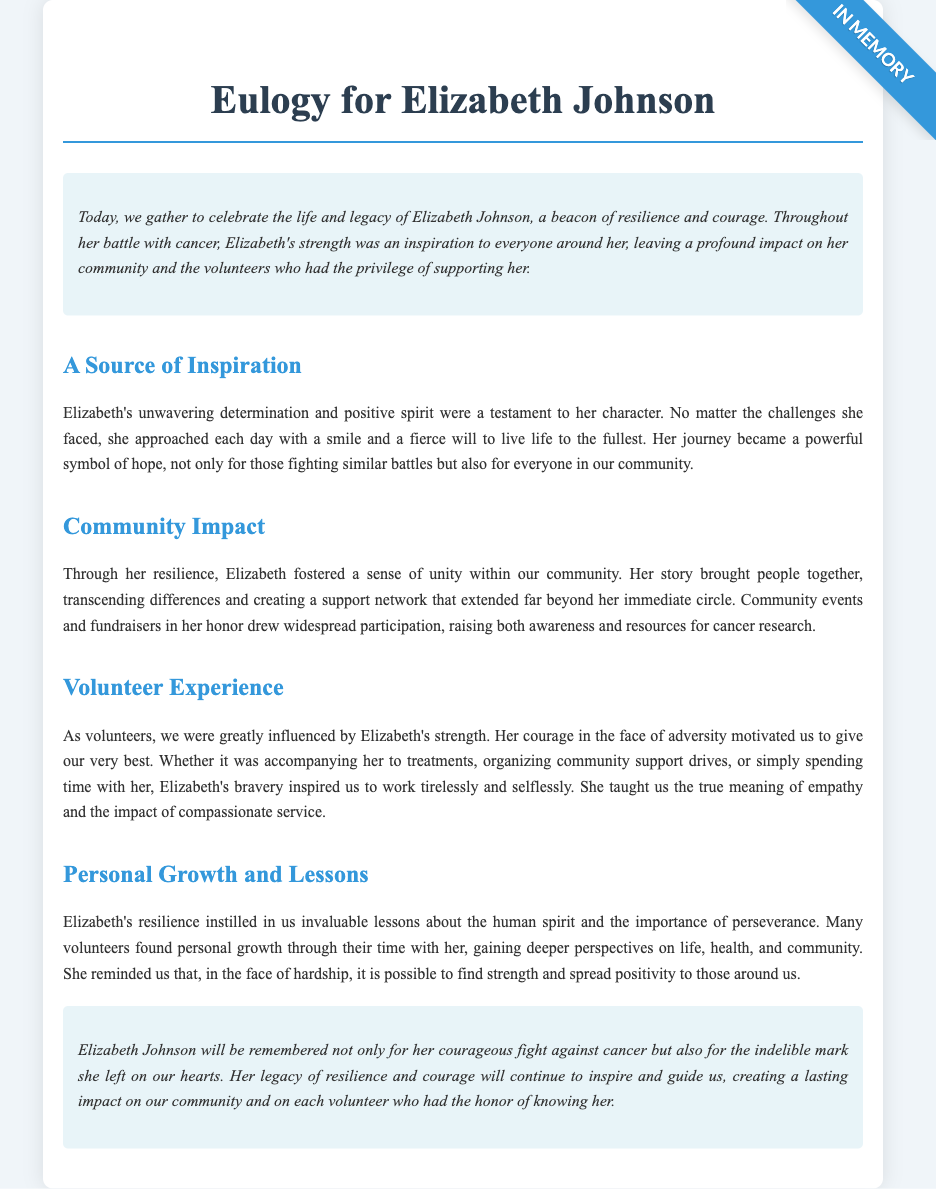What is the name of the person the eulogy is for? The document is centered around Elizabeth Johnson, as stated in the title.
Answer: Elizabeth Johnson What quality was Elizabeth known for during her battle with cancer? The eulogy highlights Elizabeth's strength as a significant aspect of her character.
Answer: Strength How did Elizabeth affect her community? The document mentions that her story created a support network and drew people together, fostering a sense of unity.
Answer: Unity What type of events were organized in Elizabeth's honor? The eulogy refers to community events and fundraisers that aimed to raise awareness and resources for cancer research.
Answer: Fundraisers What did volunteers learn from Elizabeth? The eulogy states that volunteers gained invaluable lessons about the human spirit and perseverance during their time with her.
Answer: Perseverance How is Elizabeth's legacy described? The document emphasizes that Elizabeth’s legacy is one of resilience and courage, which continues to inspire others.
Answer: Resilience and courage What was one of Elizabeth's attributes that inspired volunteers? The eulogy discusses Elizabeth's bravery as a motivating factor for volunteers during their support roles.
Answer: Bravery What was the overall tone of the eulogy regarding Elizabeth's fight against cancer? The tone is one of celebration and admiration for her courage and lasting impact on those around her.
Answer: Celebration and admiration 